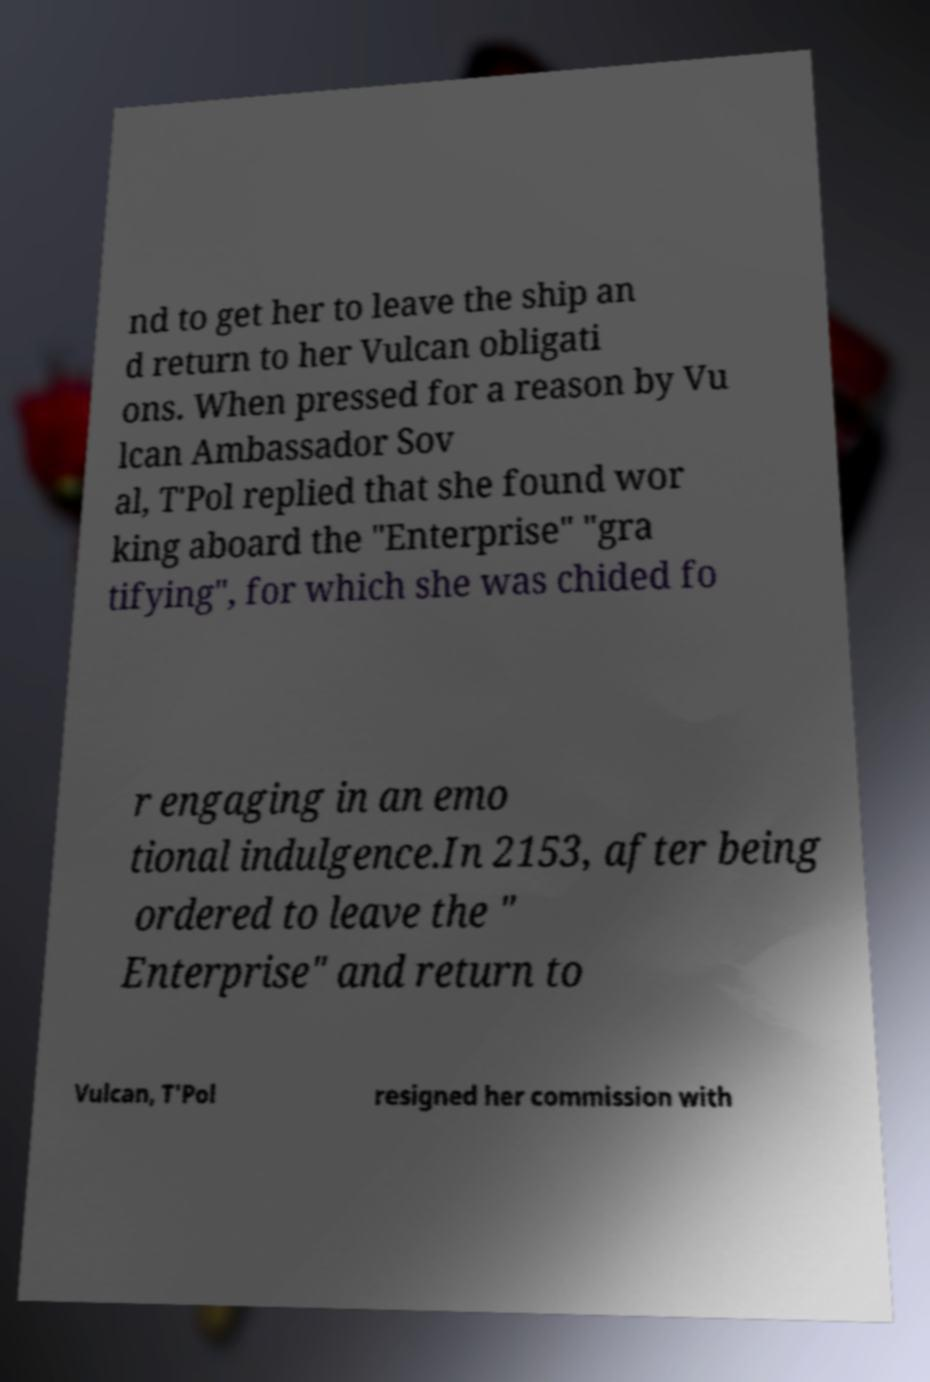Please identify and transcribe the text found in this image. nd to get her to leave the ship an d return to her Vulcan obligati ons. When pressed for a reason by Vu lcan Ambassador Sov al, T'Pol replied that she found wor king aboard the "Enterprise" "gra tifying", for which she was chided fo r engaging in an emo tional indulgence.In 2153, after being ordered to leave the " Enterprise" and return to Vulcan, T'Pol resigned her commission with 